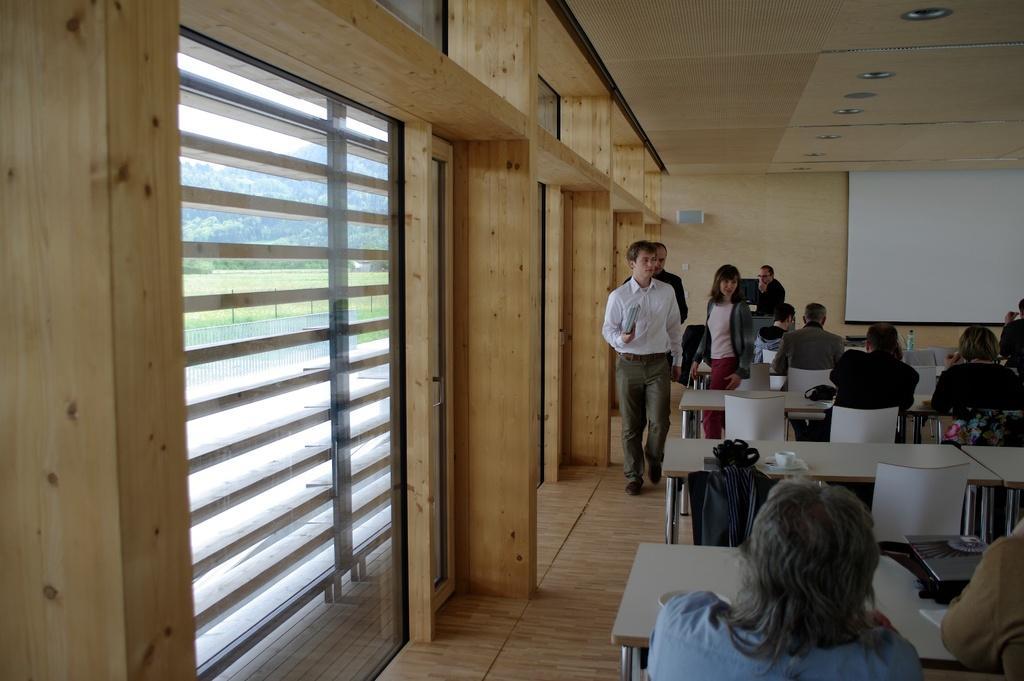Please provide a concise description of this image. In this image we can see persons sitting on the chairs and some are standing on the floor. In the background we can see display screen, blinds, ground, trees and sky. 